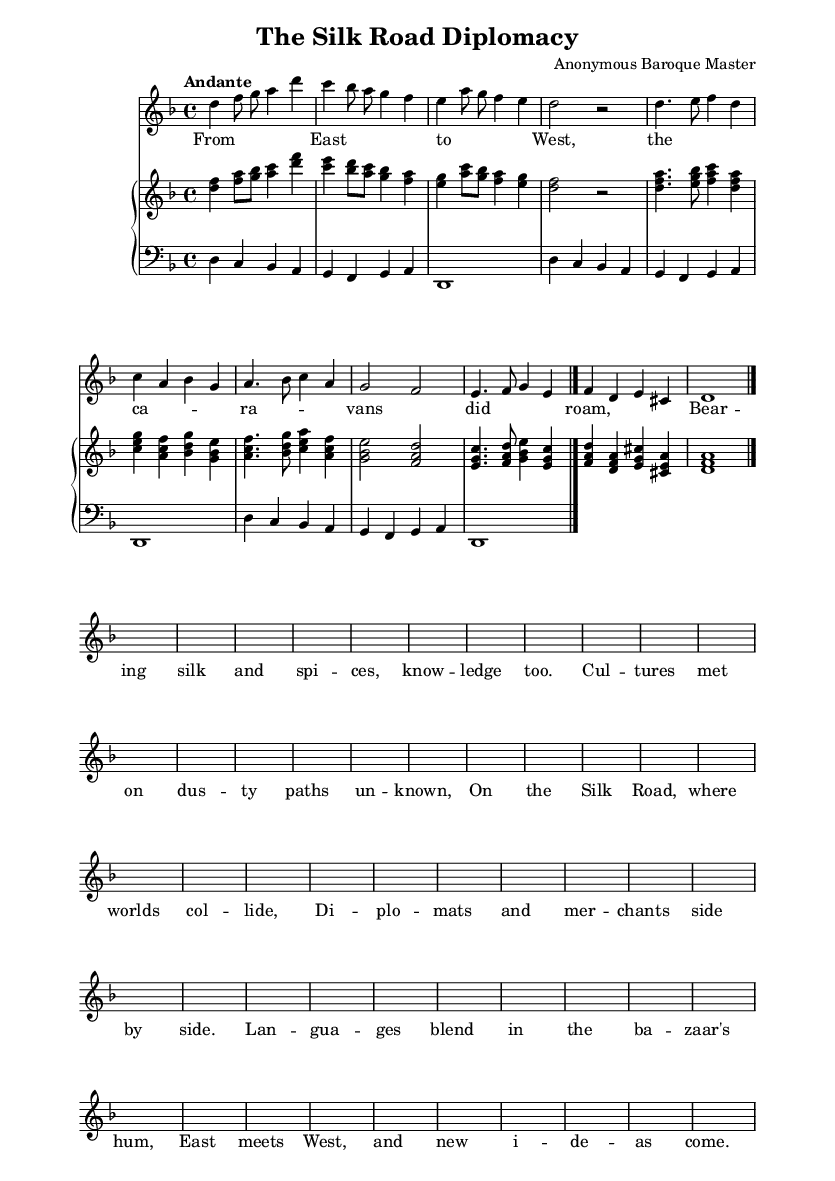What is the key signature of this music? The key signature is D minor, which has one flat (B flat). This can be determined by looking at the key signature indicated at the beginning of the score.
Answer: D minor What is the time signature of this music? The time signature is 4/4, indicated at the beginning of the score right after the key signature. This means there are four beats in each measure.
Answer: 4/4 What is the tempo marking for this piece? The tempo marking is "Andante," which typically indicates a moderately slow tempo. This is specified at the beginning of the score.
Answer: Andante How many measures are there in the soprano part? By counting each distinct group of notes and pauses (bar lines), the soprano part is divided into 8 measures. This can be seen by observing the structure of note sequences in the soprano line.
Answer: 8 What musical elements are employed in the recitative section? The recitative section features free rhythm with syllabic text setting, often enhancing narrative delivery. You can identify this by noticing the longer notes and less consistent rhythmic patterns compared to the aria.
Answer: Free rhythm What type of ensemble is typically utilized in Baroque opera as seen in this composition? The ensemble for Baroque opera frequently includes strings, continuo, and vocalists, which is indicated by the presence of the piano staff with both treble and bass clefs in this score, representing the harpsichord play alongside vocals.
Answer: Strings and continuo 